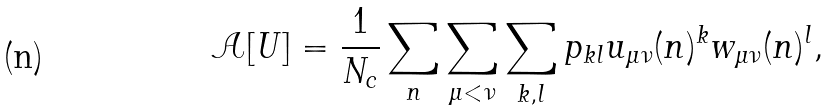<formula> <loc_0><loc_0><loc_500><loc_500>\mathcal { A } [ U ] = \frac { 1 } { N _ { c } } \sum _ { n } \sum _ { \mu < \nu } \sum _ { k , l } p _ { k l } u _ { \mu \nu } ( n ) ^ { k } w _ { \mu \nu } ( n ) ^ { l } ,</formula> 